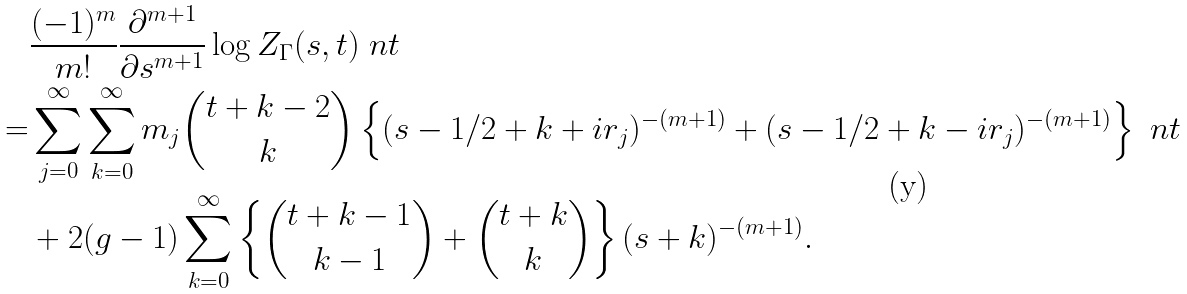<formula> <loc_0><loc_0><loc_500><loc_500>& \frac { ( - 1 ) ^ { m } } { m ! } \frac { \partial ^ { m + 1 } } { \partial s ^ { m + 1 } } \log { Z _ { \Gamma } ( s , t ) } \ n t \\ = & \sum _ { j = 0 } ^ { \infty } \sum _ { k = 0 } ^ { \infty } m _ { j } \binom { t + k - 2 } { k } \left \{ ( s - 1 / 2 + k + i r _ { j } ) ^ { - ( m + 1 ) } + ( s - 1 / 2 + k - i r _ { j } ) ^ { - ( m + 1 ) } \right \} \ n t \\ & + 2 ( g - 1 ) \sum _ { k = 0 } ^ { \infty } \left \{ \binom { t + k - 1 } { k - 1 } + \binom { t + k } { k } \right \} ( s + k ) ^ { - ( m + 1 ) } .</formula> 